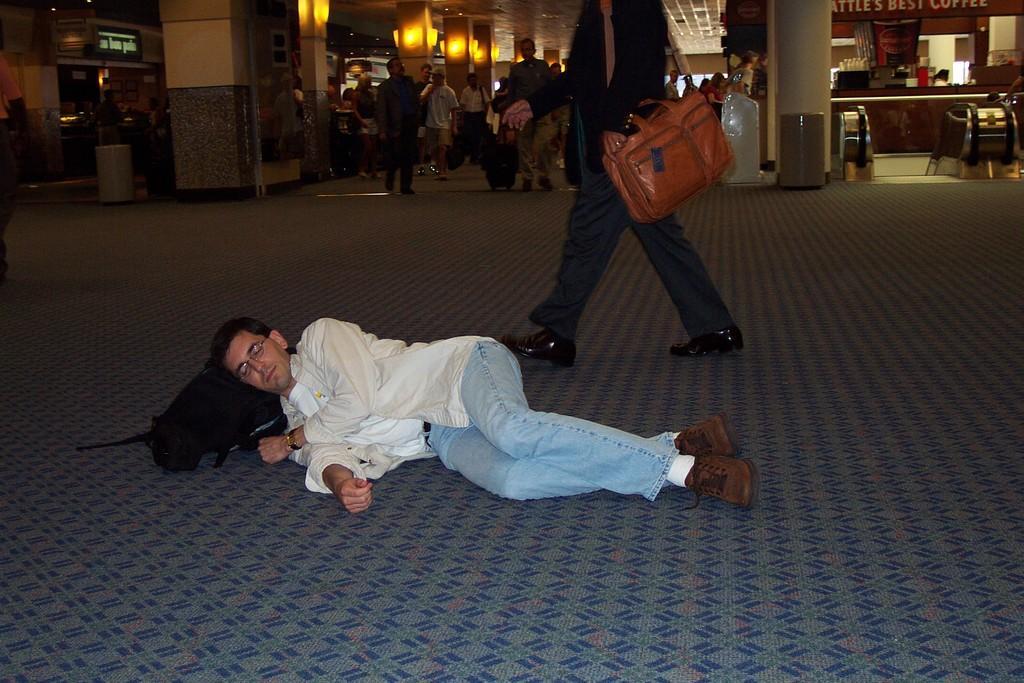In one or two sentences, can you explain what this image depicts? In this image we can see persons on the floor and one of them is lying on the bag. In the background we can see pillars, name boards, bins and stalls. 